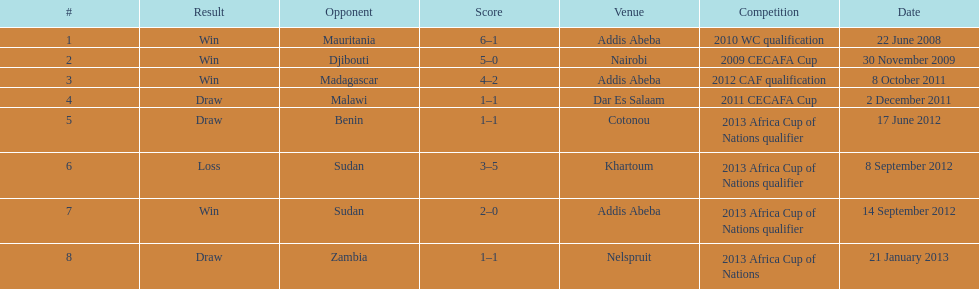For each winning game, what was their score? 6-1, 5-0, 4-2, 2-0. Give me the full table as a dictionary. {'header': ['#', 'Result', 'Opponent', 'Score', 'Venue', 'Competition', 'Date'], 'rows': [['1', 'Win', 'Mauritania', '6–1', 'Addis Abeba', '2010 WC qualification', '22 June 2008'], ['2', 'Win', 'Djibouti', '5–0', 'Nairobi', '2009 CECAFA Cup', '30 November 2009'], ['3', 'Win', 'Madagascar', '4–2', 'Addis Abeba', '2012 CAF qualification', '8 October 2011'], ['4', 'Draw', 'Malawi', '1–1', 'Dar Es Salaam', '2011 CECAFA Cup', '2 December 2011'], ['5', 'Draw', 'Benin', '1–1', 'Cotonou', '2013 Africa Cup of Nations qualifier', '17 June 2012'], ['6', 'Loss', 'Sudan', '3–5', 'Khartoum', '2013 Africa Cup of Nations qualifier', '8 September 2012'], ['7', 'Win', 'Sudan', '2–0', 'Addis Abeba', '2013 Africa Cup of Nations qualifier', '14 September 2012'], ['8', 'Draw', 'Zambia', '1–1', 'Nelspruit', '2013 Africa Cup of Nations', '21 January 2013']]} 